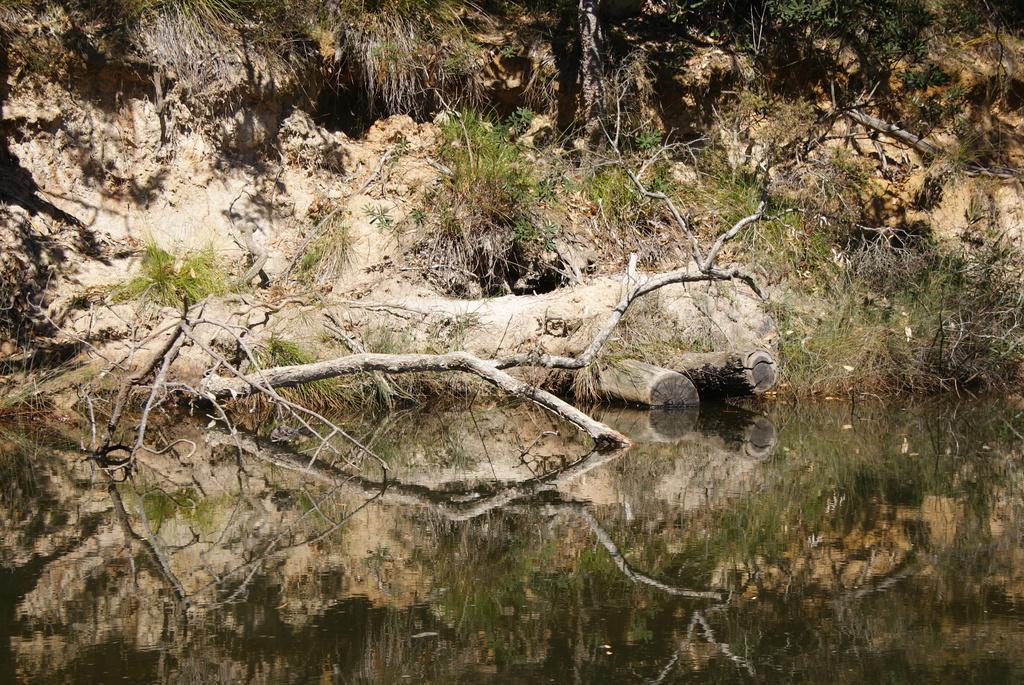Please provide a concise description of this image. In the picture there is water, beside the water there are plants and there is a branch, on the water we can see the reflection of the plants and the branch. 